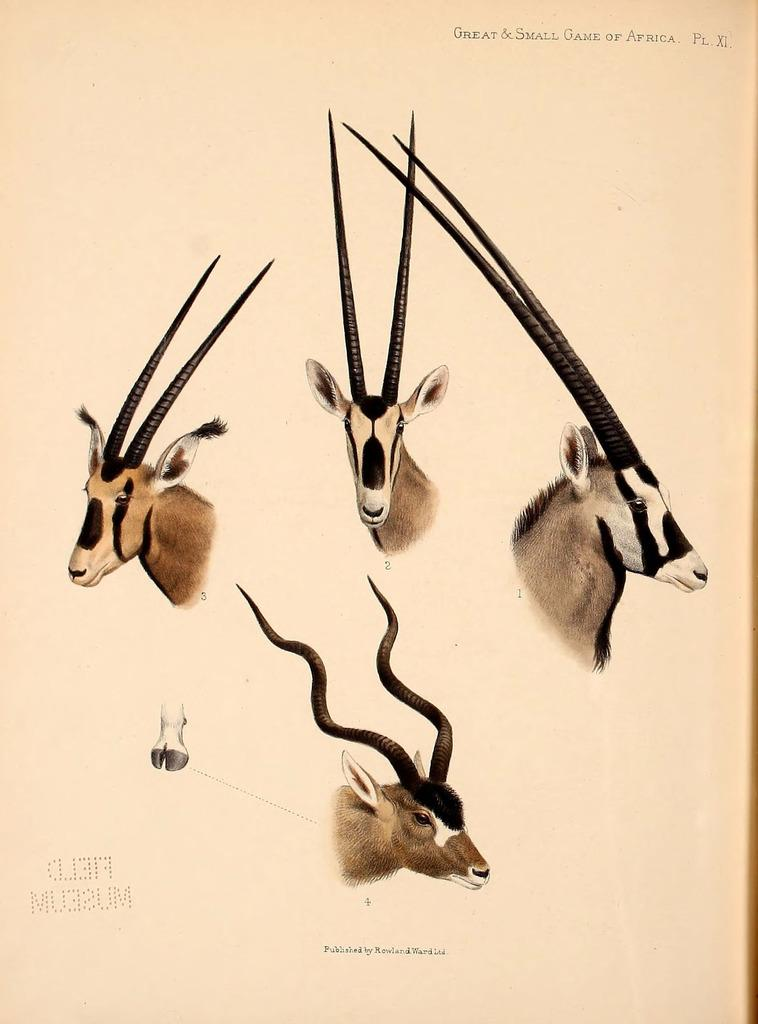What is depicted in the image? There is a painting of goats in the image. What medium is the painting created on? The painting is on paper. Where is the throne located in the image? There is no throne present in the image; it only features a painting of goats on paper. 